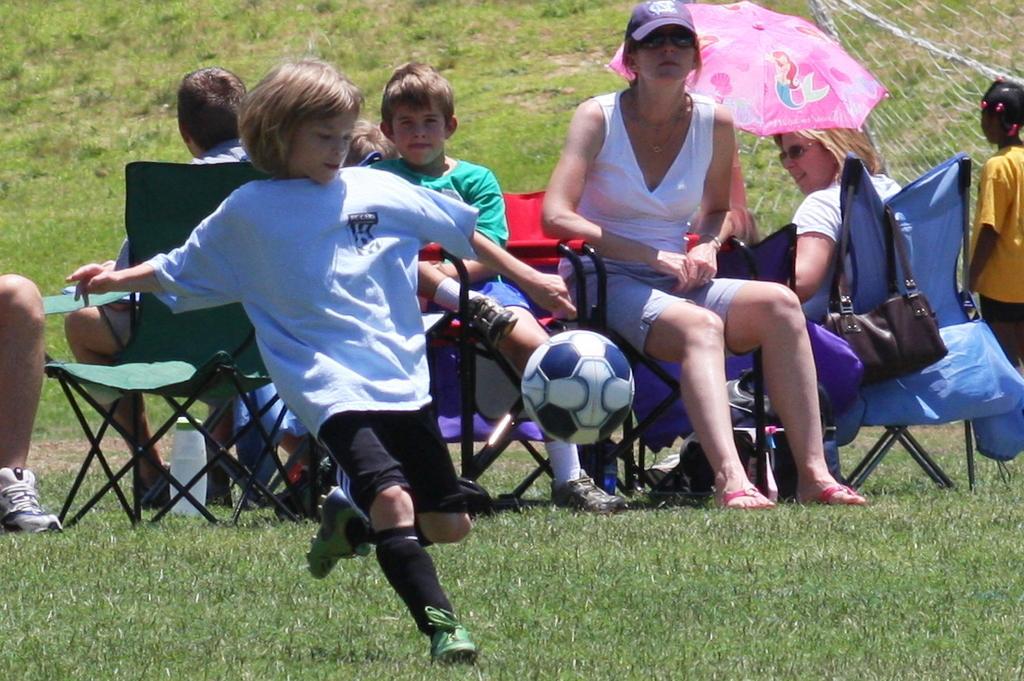Could you give a brief overview of what you see in this image? In this image there some people who are sitting in front of the image there is one boy who is running towards ball and some grass is there on the bottom of the image in the middle of the image there is one woman who is sitting on a chair and she is wearing a cap and goggles and she is wearing a white shirt and on the right side there is one chair and hand bag is there on the chair. 